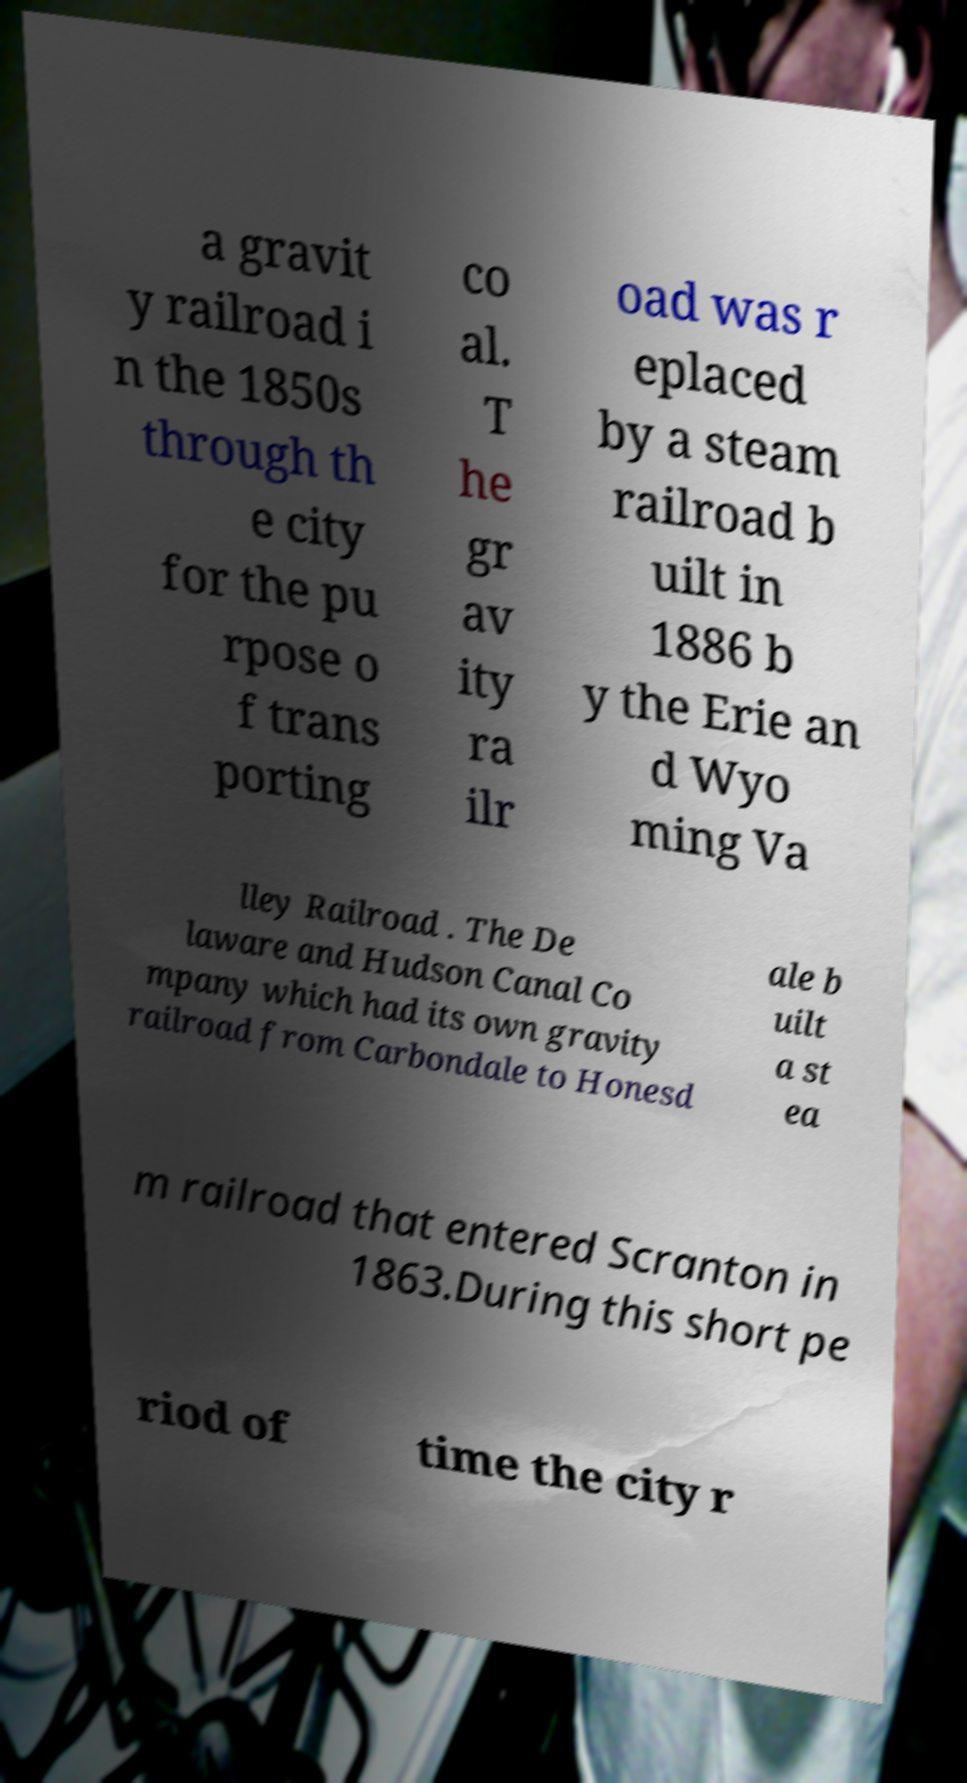Could you assist in decoding the text presented in this image and type it out clearly? a gravit y railroad i n the 1850s through th e city for the pu rpose o f trans porting co al. T he gr av ity ra ilr oad was r eplaced by a steam railroad b uilt in 1886 b y the Erie an d Wyo ming Va lley Railroad . The De laware and Hudson Canal Co mpany which had its own gravity railroad from Carbondale to Honesd ale b uilt a st ea m railroad that entered Scranton in 1863.During this short pe riod of time the city r 